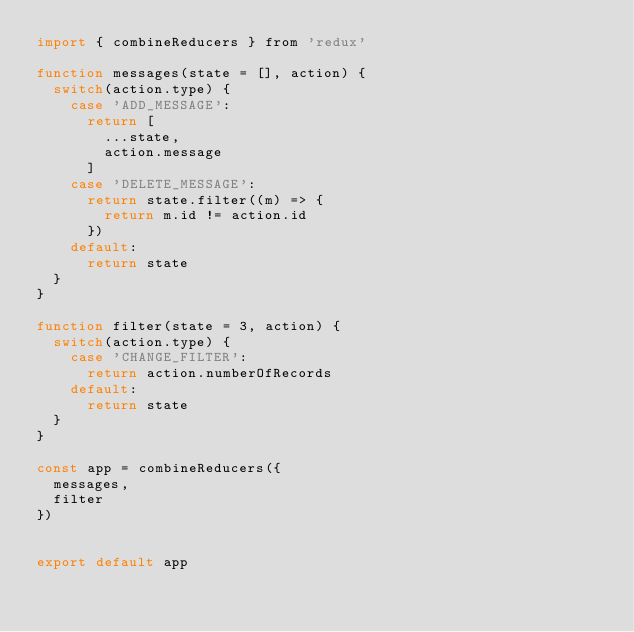<code> <loc_0><loc_0><loc_500><loc_500><_JavaScript_>import { combineReducers } from 'redux'

function messages(state = [], action) {
  switch(action.type) {
    case 'ADD_MESSAGE':
      return [
        ...state,
        action.message
      ]
    case 'DELETE_MESSAGE':
      return state.filter((m) => {
        return m.id != action.id
      })
    default:
      return state
  }
}

function filter(state = 3, action) {
  switch(action.type) {
    case 'CHANGE_FILTER':
      return action.numberOfRecords
    default:
      return state
  }
}

const app = combineReducers({
  messages,
  filter
})


export default app
</code> 